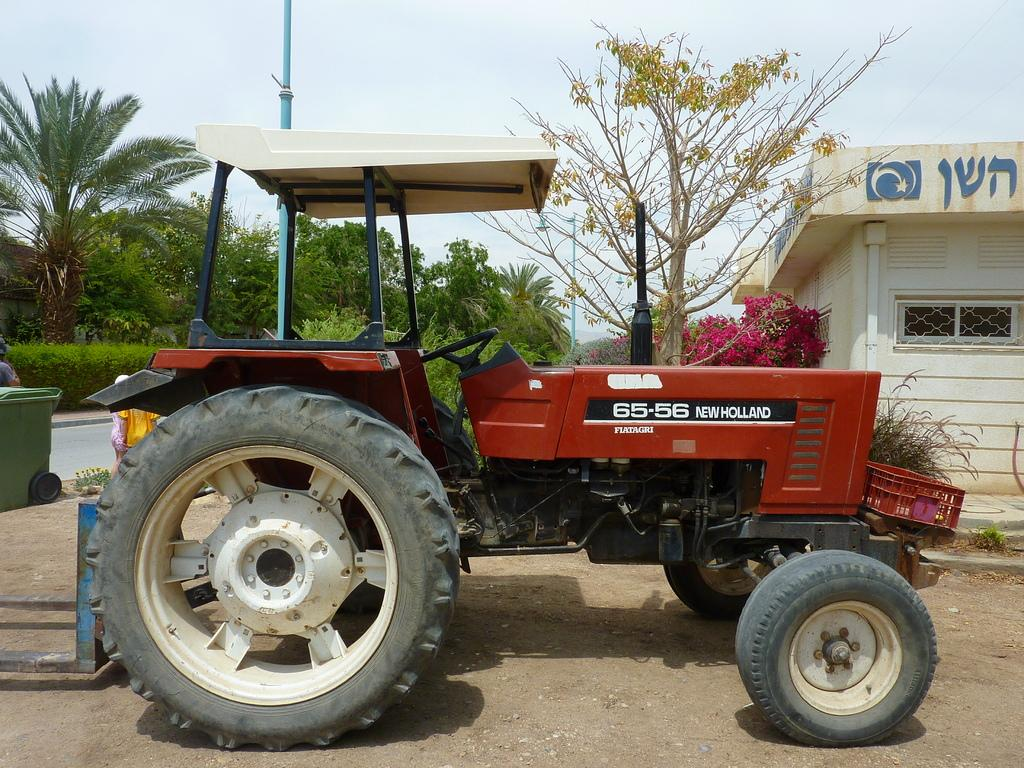What is the main subject in the middle of the image? There is a tractor in the middle of the image. What can be seen near the tractor? There are people near the tractor. What object is present in the image that is typically used for waste disposal? There is a dustbin in the image. What can be seen in the background of the image? There are trees, poles, and a house in the background of the image. How many babies are crawling on the tractor in the image? There are no babies present in the image; it features a tractor with people nearby. 